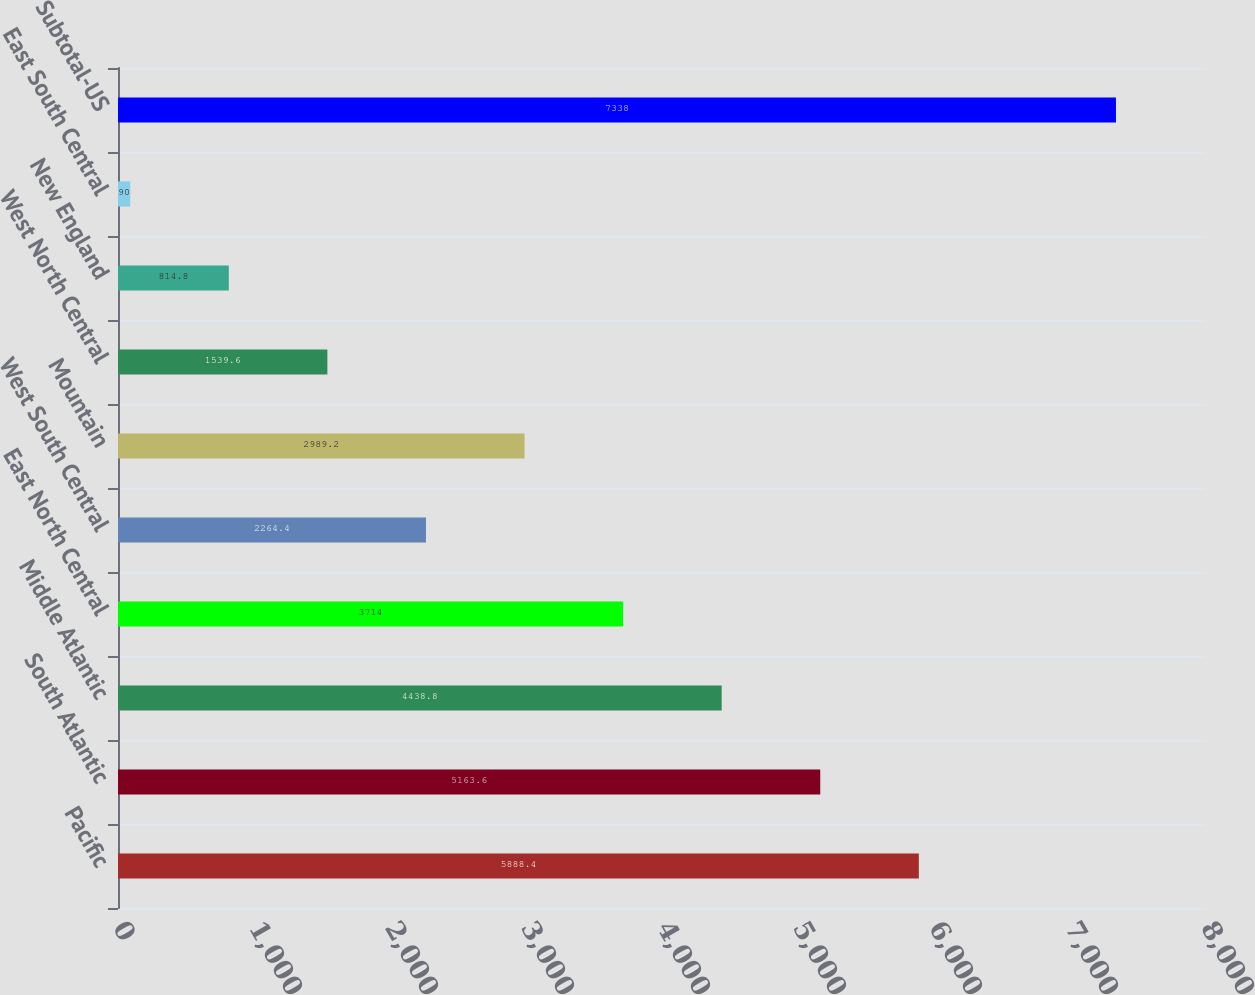Convert chart to OTSL. <chart><loc_0><loc_0><loc_500><loc_500><bar_chart><fcel>Pacific<fcel>South Atlantic<fcel>Middle Atlantic<fcel>East North Central<fcel>West South Central<fcel>Mountain<fcel>West North Central<fcel>New England<fcel>East South Central<fcel>Subtotal-US<nl><fcel>5888.4<fcel>5163.6<fcel>4438.8<fcel>3714<fcel>2264.4<fcel>2989.2<fcel>1539.6<fcel>814.8<fcel>90<fcel>7338<nl></chart> 